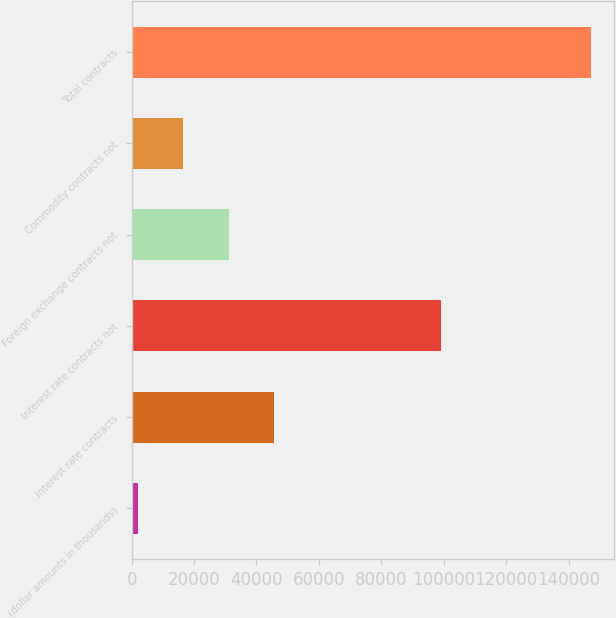Convert chart to OTSL. <chart><loc_0><loc_0><loc_500><loc_500><bar_chart><fcel>(dollar amounts in thousands)<fcel>Interest rate contracts<fcel>Interest rate contracts not<fcel>Foreign exchange contracts not<fcel>Commodity contracts not<fcel>Total contracts<nl><fcel>2013<fcel>45603.6<fcel>99247<fcel>31073.4<fcel>16543.2<fcel>147315<nl></chart> 